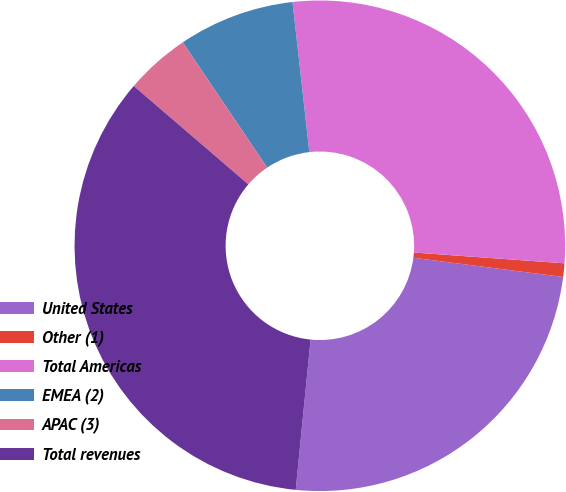Convert chart to OTSL. <chart><loc_0><loc_0><loc_500><loc_500><pie_chart><fcel>United States<fcel>Other (1)<fcel>Total Americas<fcel>EMEA (2)<fcel>APAC (3)<fcel>Total revenues<nl><fcel>24.54%<fcel>0.89%<fcel>27.92%<fcel>7.66%<fcel>4.27%<fcel>34.72%<nl></chart> 